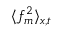<formula> <loc_0><loc_0><loc_500><loc_500>\langle f _ { m } ^ { 2 } \rangle _ { x , t }</formula> 